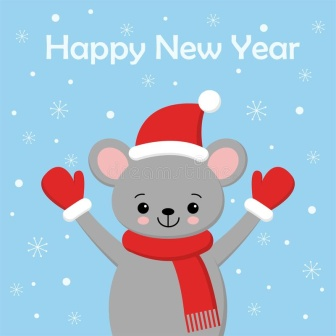Imagine this mouse could talk. What message would it be delivering? If the mouse could talk, it would likely deliver a heartfelt and warm message filled with holiday cheer. Perhaps it would say, 'Hello, friends! I just wanted to take a moment to wish you all a very Happy New Year! May this year bring you abundant joy, laughter, and unforgettable moments. Remember to cherish every precious moment and spread kindness wherever you go. Let's make this year the best one yet!' The adorable mouse’s enthusiastic expression and festive attire would make this message even more endearing and uplifting. How do you think the mouse prepares for a festival like New Year? In our whimsical imagination, the mouse would start preparing for the New Year festival early with lots of enthusiasm and creativity. It would decorate its cozy little home with string lights, tiny ornaments, and perhaps even a small Christmas tree. The mouse would bake delightful little cookies shaped like stars and snowflakes, filling its home with the sweet aroma of festive treats. It would also invite its friends, possibly other cute animals, to join in the celebrations. They might play in the snow, sing carols, and share stories by the fireplace. The final touch would be getting dressed in its festive red mittens and Santa hat, ready to spread cheer and joy as the clock strikes midnight, welcoming the New Year together with its loved ones. 